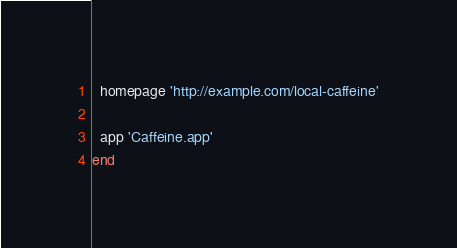Convert code to text. <code><loc_0><loc_0><loc_500><loc_500><_Ruby_>  homepage 'http://example.com/local-caffeine'

  app 'Caffeine.app'
end
</code> 